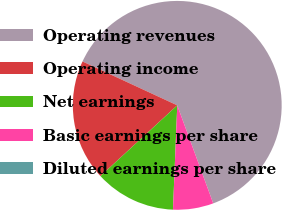<chart> <loc_0><loc_0><loc_500><loc_500><pie_chart><fcel>Operating revenues<fcel>Operating income<fcel>Net earnings<fcel>Basic earnings per share<fcel>Diluted earnings per share<nl><fcel>62.5%<fcel>18.75%<fcel>12.5%<fcel>6.25%<fcel>0.0%<nl></chart> 